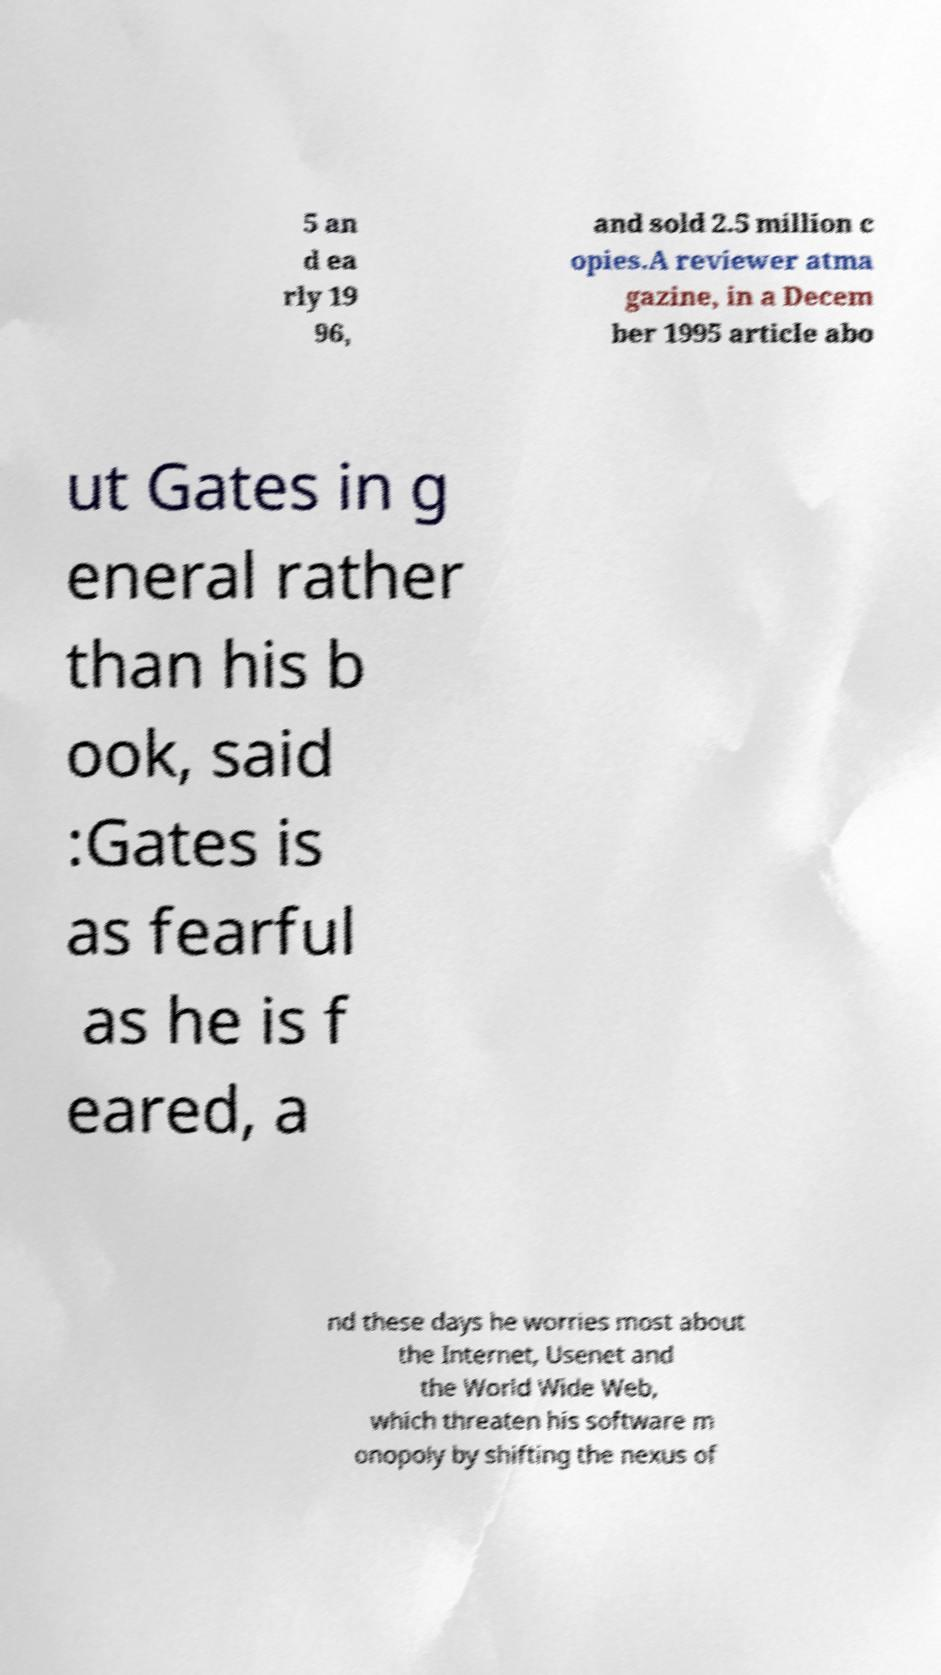I need the written content from this picture converted into text. Can you do that? 5 an d ea rly 19 96, and sold 2.5 million c opies.A reviewer atma gazine, in a Decem ber 1995 article abo ut Gates in g eneral rather than his b ook, said :Gates is as fearful as he is f eared, a nd these days he worries most about the Internet, Usenet and the World Wide Web, which threaten his software m onopoly by shifting the nexus of 